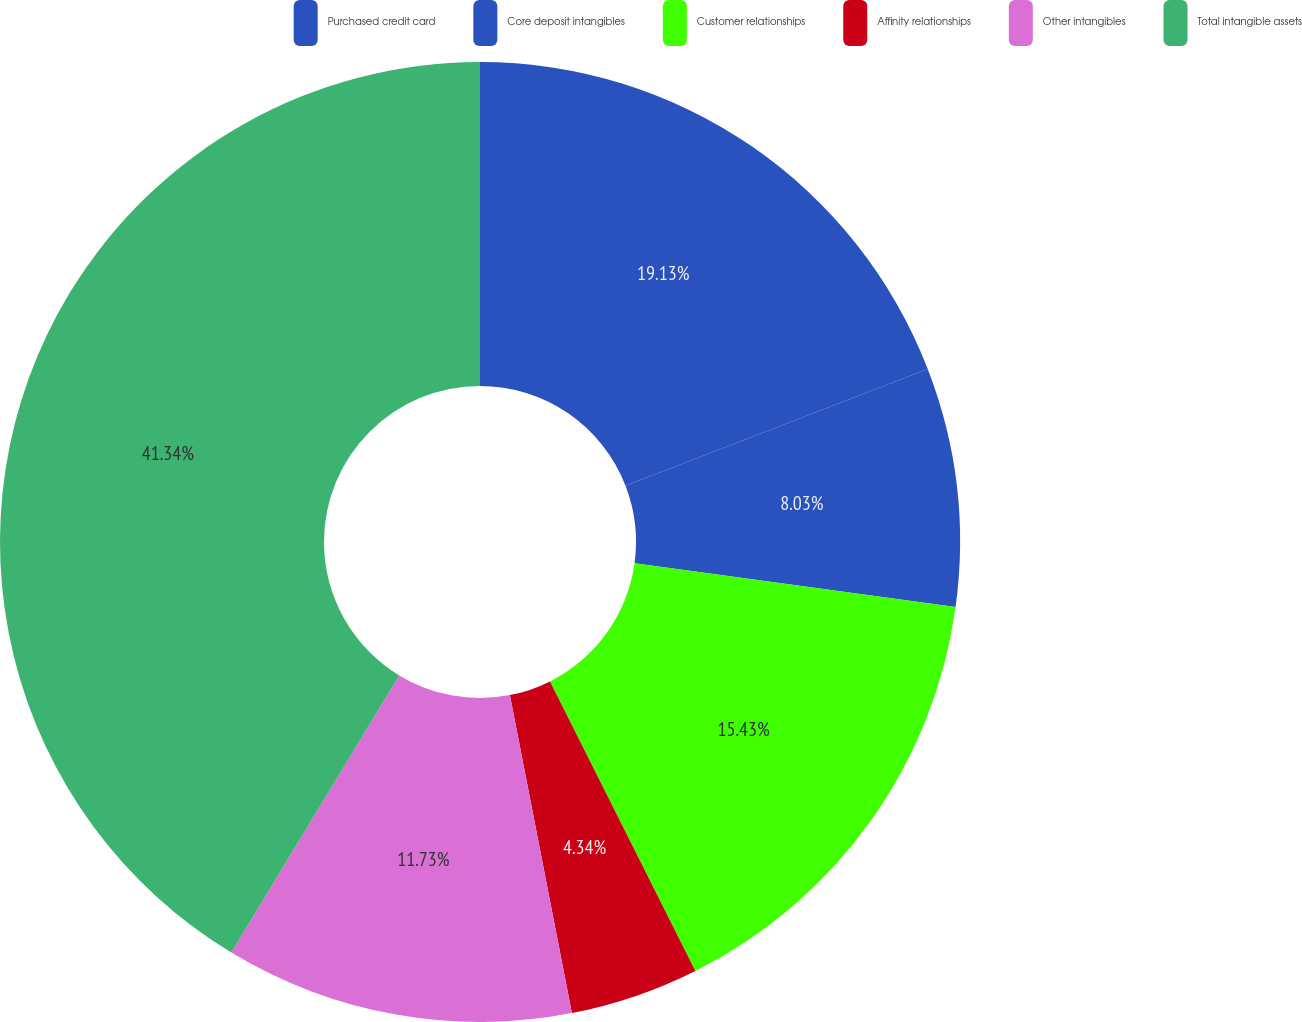<chart> <loc_0><loc_0><loc_500><loc_500><pie_chart><fcel>Purchased credit card<fcel>Core deposit intangibles<fcel>Customer relationships<fcel>Affinity relationships<fcel>Other intangibles<fcel>Total intangible assets<nl><fcel>19.13%<fcel>8.03%<fcel>15.43%<fcel>4.34%<fcel>11.73%<fcel>41.33%<nl></chart> 